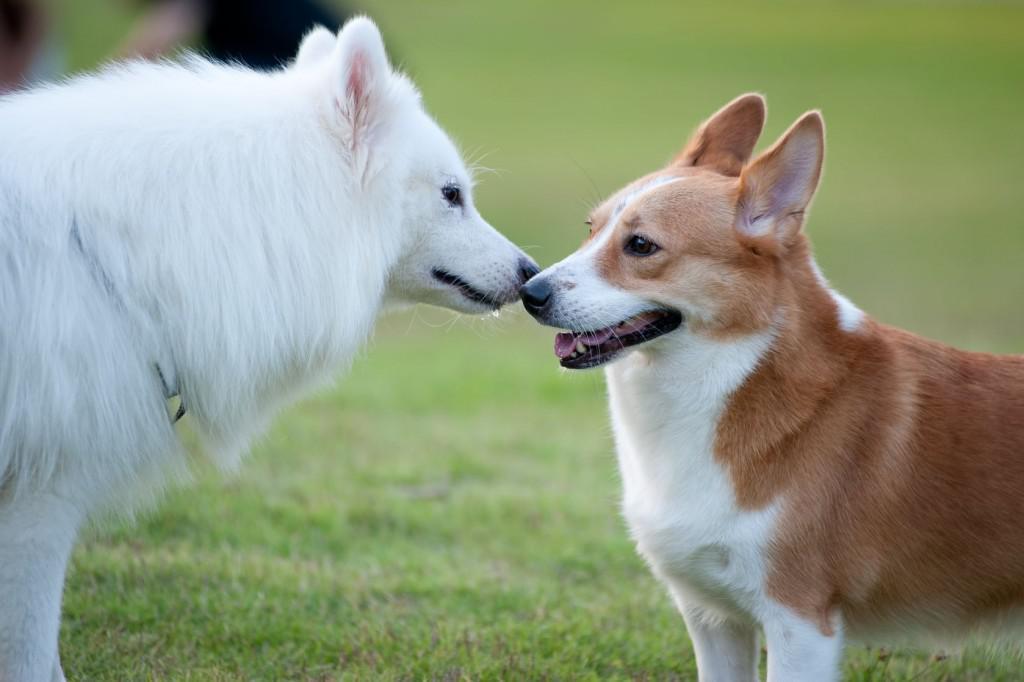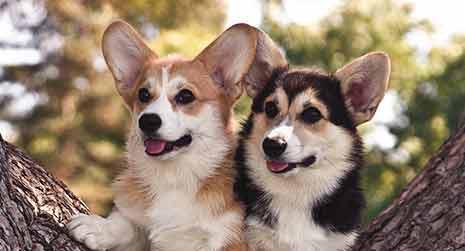The first image is the image on the left, the second image is the image on the right. For the images displayed, is the sentence "Two of the corgis are running with their mouths hanging open, the other two are sitting facing towards the camera." factually correct? Answer yes or no. No. The first image is the image on the left, the second image is the image on the right. For the images displayed, is the sentence "An image shows two short-legged dogs running across a grassy area." factually correct? Answer yes or no. No. 